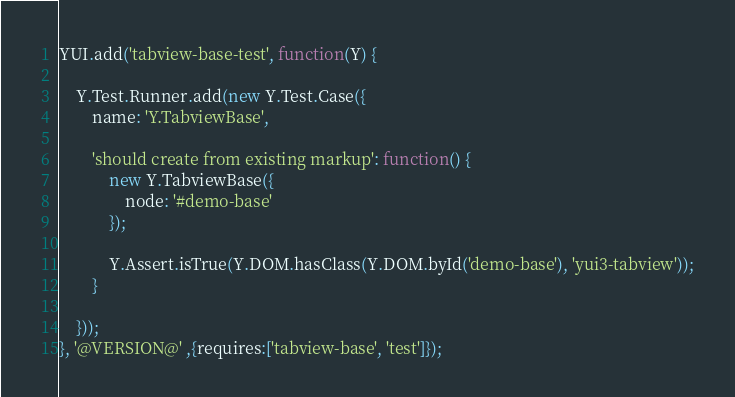Convert code to text. <code><loc_0><loc_0><loc_500><loc_500><_JavaScript_>YUI.add('tabview-base-test', function(Y) {

    Y.Test.Runner.add(new Y.Test.Case({
        name: 'Y.TabviewBase',

        'should create from existing markup': function() {
            new Y.TabviewBase({
                node: '#demo-base'
            });

            Y.Assert.isTrue(Y.DOM.hasClass(Y.DOM.byId('demo-base'), 'yui3-tabview'));
        }            

    })); 
}, '@VERSION@' ,{requires:['tabview-base', 'test']});
</code> 